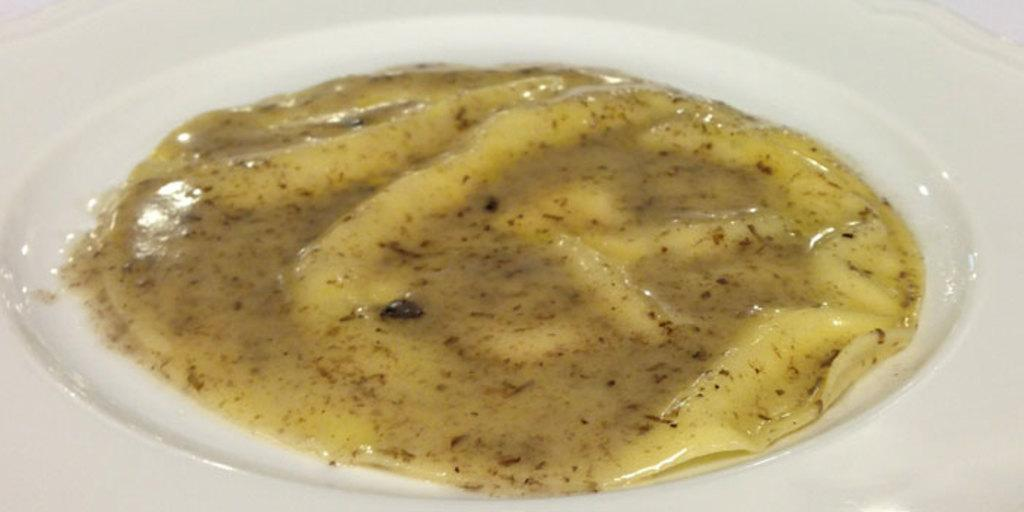What can be seen on the plate in the image? There is food present on the plate in the image. What emotion does the food on the plate display in the image? The food on the plate does not display any emotions, as it is an inanimate object. 